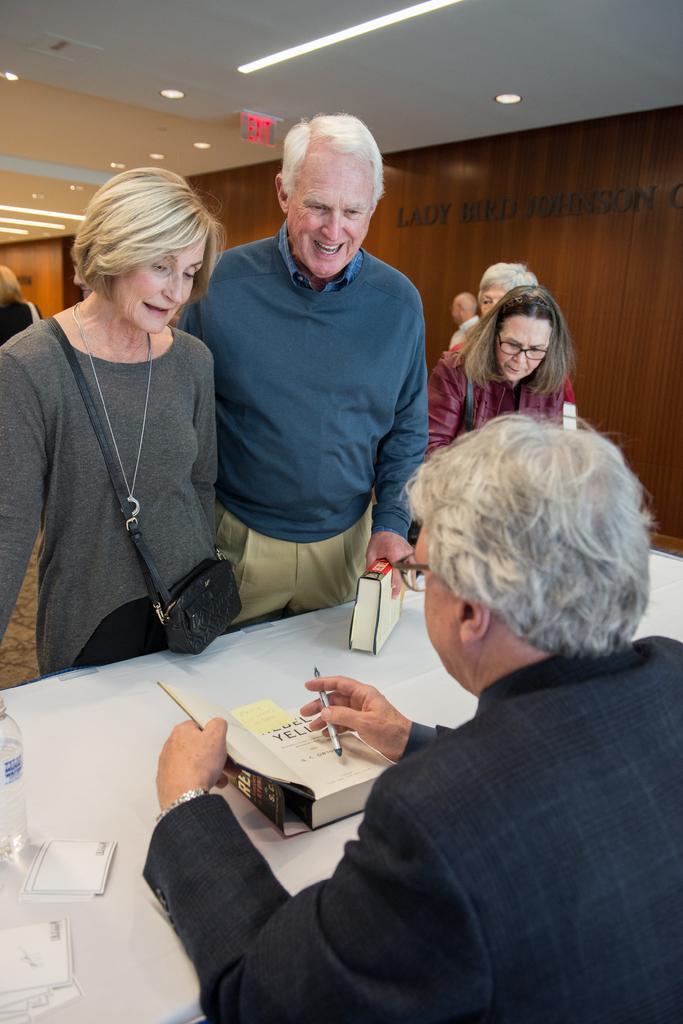Describe this image in one or two sentences. In this image I can see six people standing among which two people facing towards the back. People standing in the center are interacting with a person sitting in front of a table holding a book and a pen in a hand, I can see a bottle and other labels on the table 